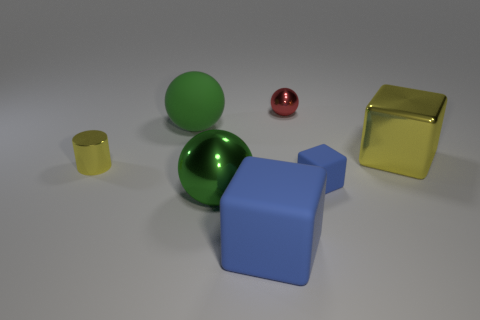Subtract all tiny red shiny spheres. How many spheres are left? 2 Subtract all blue spheres. How many blue blocks are left? 2 Add 3 matte cubes. How many objects exist? 10 Subtract all yellow balls. Subtract all purple cylinders. How many balls are left? 3 Subtract all balls. How many objects are left? 4 Subtract 1 yellow cylinders. How many objects are left? 6 Subtract all rubber cubes. Subtract all big metallic balls. How many objects are left? 4 Add 1 tiny yellow cylinders. How many tiny yellow cylinders are left? 2 Add 5 purple objects. How many purple objects exist? 5 